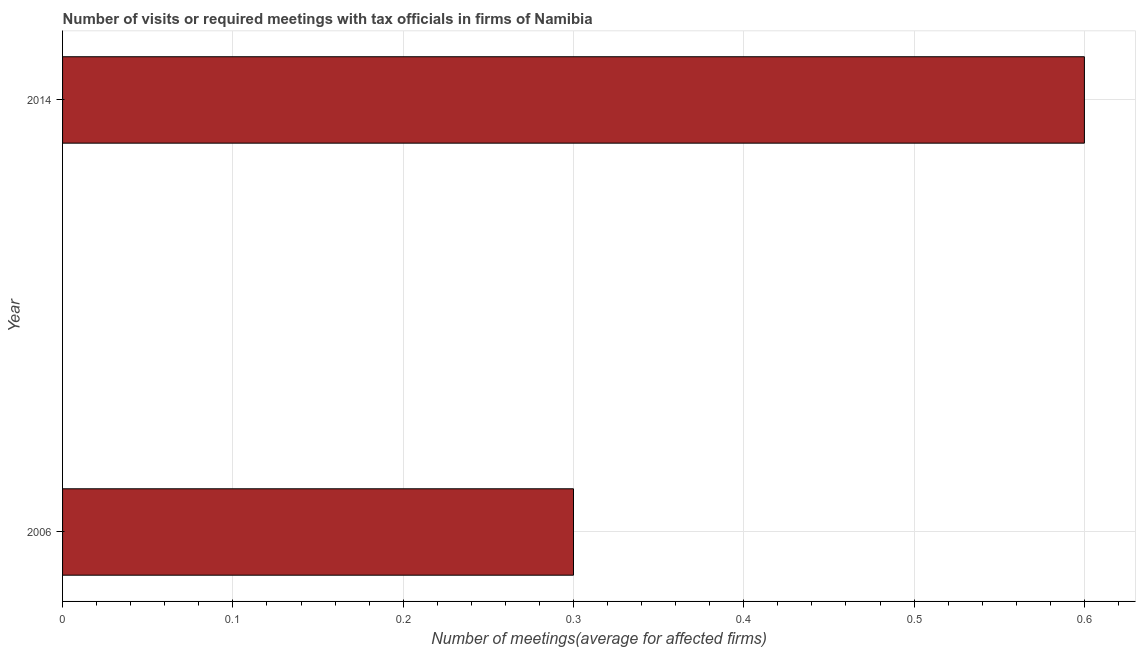Does the graph contain grids?
Ensure brevity in your answer.  Yes. What is the title of the graph?
Your answer should be very brief. Number of visits or required meetings with tax officials in firms of Namibia. What is the label or title of the X-axis?
Your answer should be compact. Number of meetings(average for affected firms). What is the label or title of the Y-axis?
Your response must be concise. Year. What is the number of required meetings with tax officials in 2006?
Keep it short and to the point. 0.3. Across all years, what is the maximum number of required meetings with tax officials?
Provide a succinct answer. 0.6. Across all years, what is the minimum number of required meetings with tax officials?
Ensure brevity in your answer.  0.3. In which year was the number of required meetings with tax officials maximum?
Your answer should be compact. 2014. What is the sum of the number of required meetings with tax officials?
Give a very brief answer. 0.9. What is the difference between the number of required meetings with tax officials in 2006 and 2014?
Give a very brief answer. -0.3. What is the average number of required meetings with tax officials per year?
Ensure brevity in your answer.  0.45. What is the median number of required meetings with tax officials?
Your answer should be very brief. 0.45. Is the number of required meetings with tax officials in 2006 less than that in 2014?
Provide a short and direct response. Yes. In how many years, is the number of required meetings with tax officials greater than the average number of required meetings with tax officials taken over all years?
Give a very brief answer. 1. What is the difference between two consecutive major ticks on the X-axis?
Keep it short and to the point. 0.1. What is the Number of meetings(average for affected firms) of 2014?
Provide a succinct answer. 0.6. What is the difference between the Number of meetings(average for affected firms) in 2006 and 2014?
Your answer should be very brief. -0.3. 